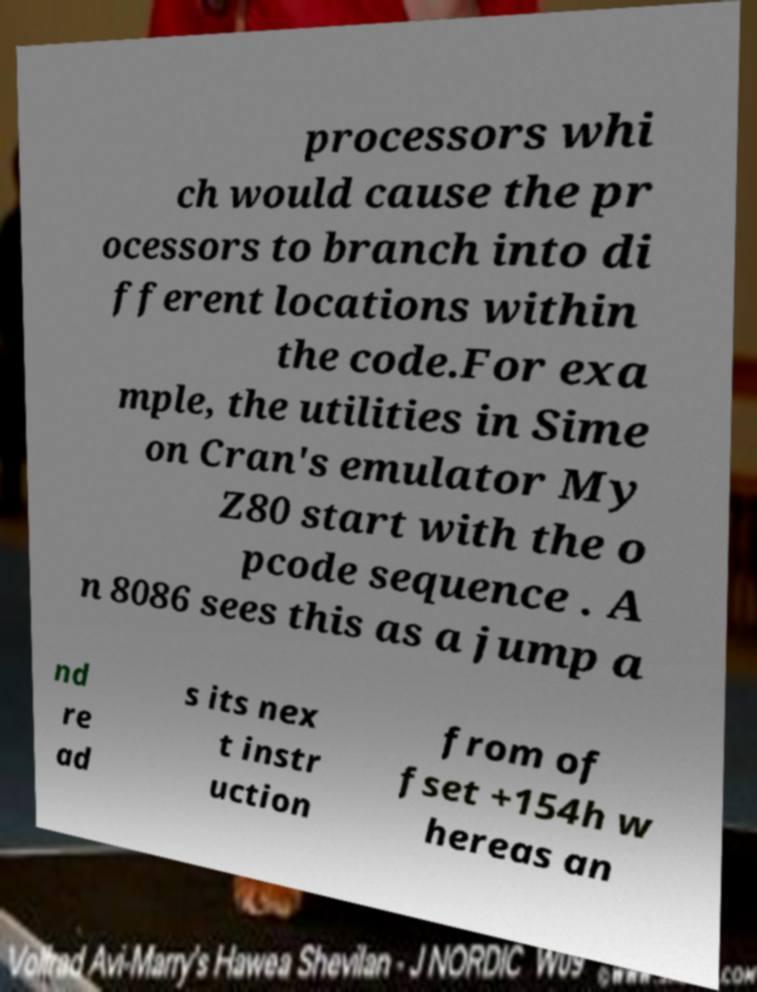Could you extract and type out the text from this image? processors whi ch would cause the pr ocessors to branch into di fferent locations within the code.For exa mple, the utilities in Sime on Cran's emulator My Z80 start with the o pcode sequence . A n 8086 sees this as a jump a nd re ad s its nex t instr uction from of fset +154h w hereas an 